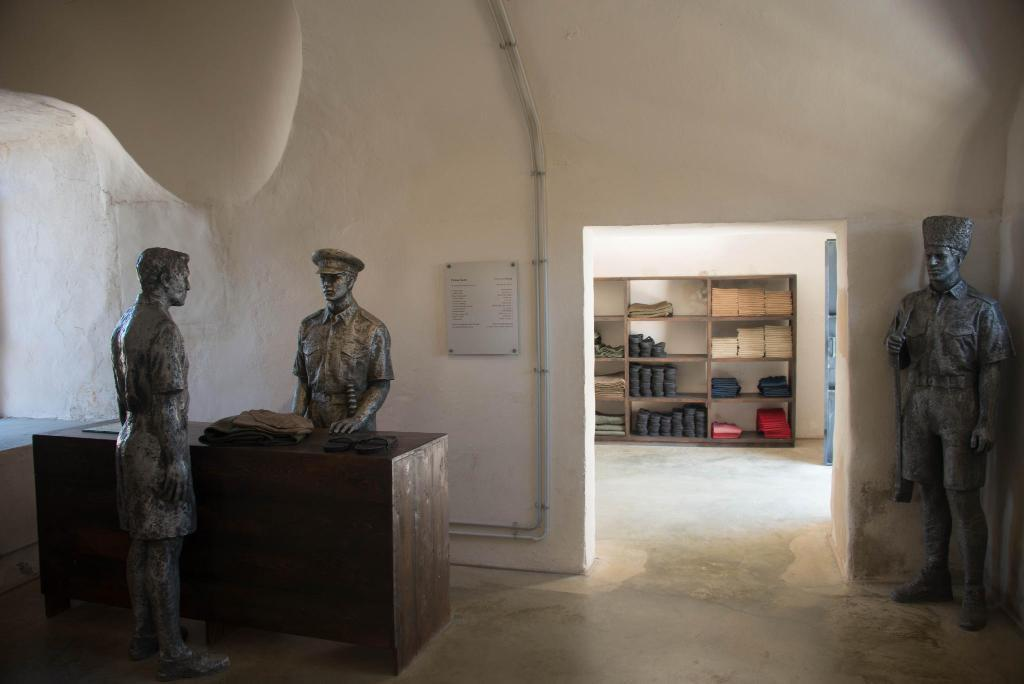How many statues are on the floor in the image? There are three statues on the floor in the image. What else can be seen in the image besides the statues? There is a board, a table, and a cupboard with items placed in it. Can you describe the table in the image? The table is a piece of furniture that can be used for various purposes, such as holding objects or providing a surface for activities. What is inside the cupboard in the image? The provided facts do not specify what is inside the cupboard, so we cannot answer that question definitively. What type of leaf is on the head of the statue in the image? There is no leaf or head of a statue present in the image. 